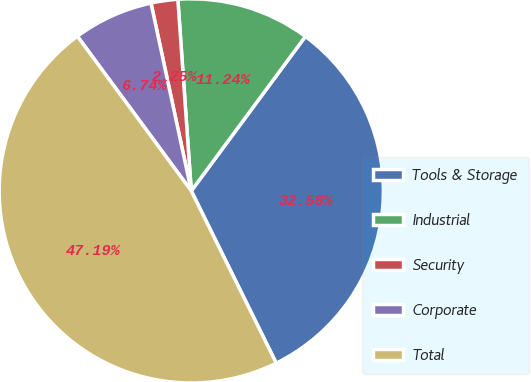Convert chart. <chart><loc_0><loc_0><loc_500><loc_500><pie_chart><fcel>Tools & Storage<fcel>Industrial<fcel>Security<fcel>Corporate<fcel>Total<nl><fcel>32.58%<fcel>11.24%<fcel>2.25%<fcel>6.74%<fcel>47.19%<nl></chart> 